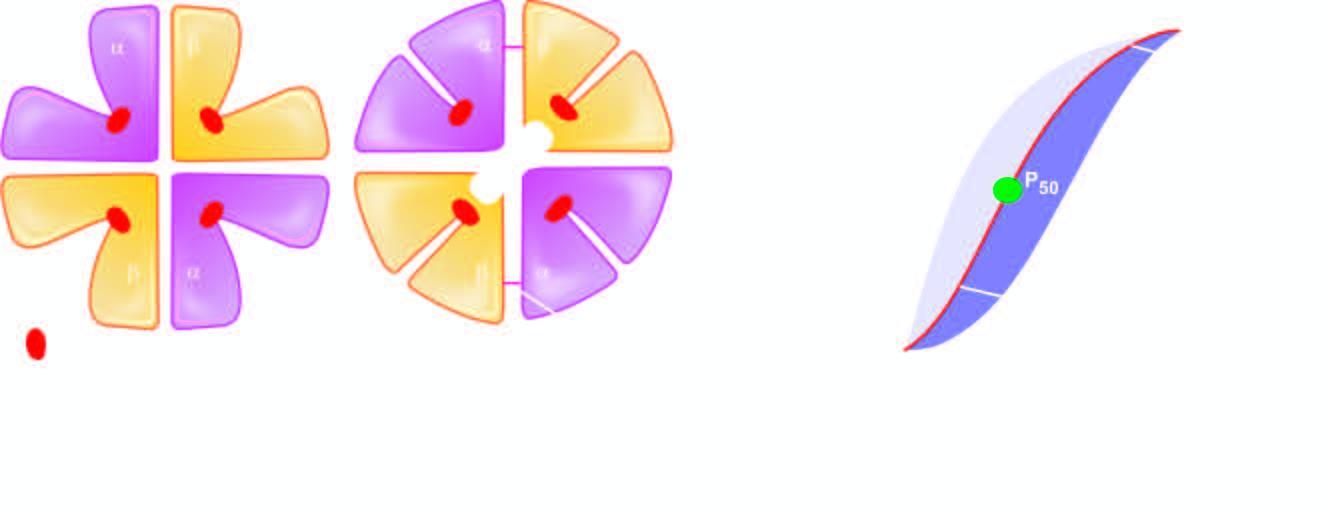s the background affected by acidic ph?
Answer the question using a single word or phrase. No 